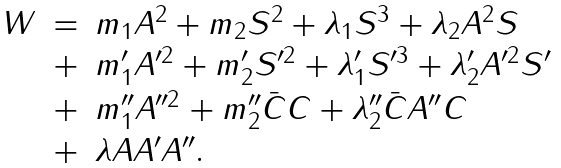<formula> <loc_0><loc_0><loc_500><loc_500>\begin{array} { l c l } W & = & m _ { 1 } A ^ { 2 } + m _ { 2 } S ^ { 2 } + \lambda _ { 1 } S ^ { 3 } + \lambda _ { 2 } A ^ { 2 } S \strut \\ & + & m _ { 1 } ^ { \prime } A ^ { \prime 2 } + m _ { 2 } ^ { \prime } S ^ { \prime 2 } + \lambda _ { 1 } ^ { \prime } S ^ { \prime 3 } + \lambda _ { 2 } ^ { \prime } A ^ { \prime 2 } S ^ { \prime } \strut \\ & + & m _ { 1 } ^ { \prime \prime } A ^ { \prime \prime 2 } + m _ { 2 } ^ { \prime \prime } \bar { C } C + \lambda _ { 2 } ^ { \prime \prime } \bar { C } A ^ { \prime \prime } C \strut \\ & + & \lambda A A ^ { \prime } A ^ { \prime \prime } . \end{array}</formula> 